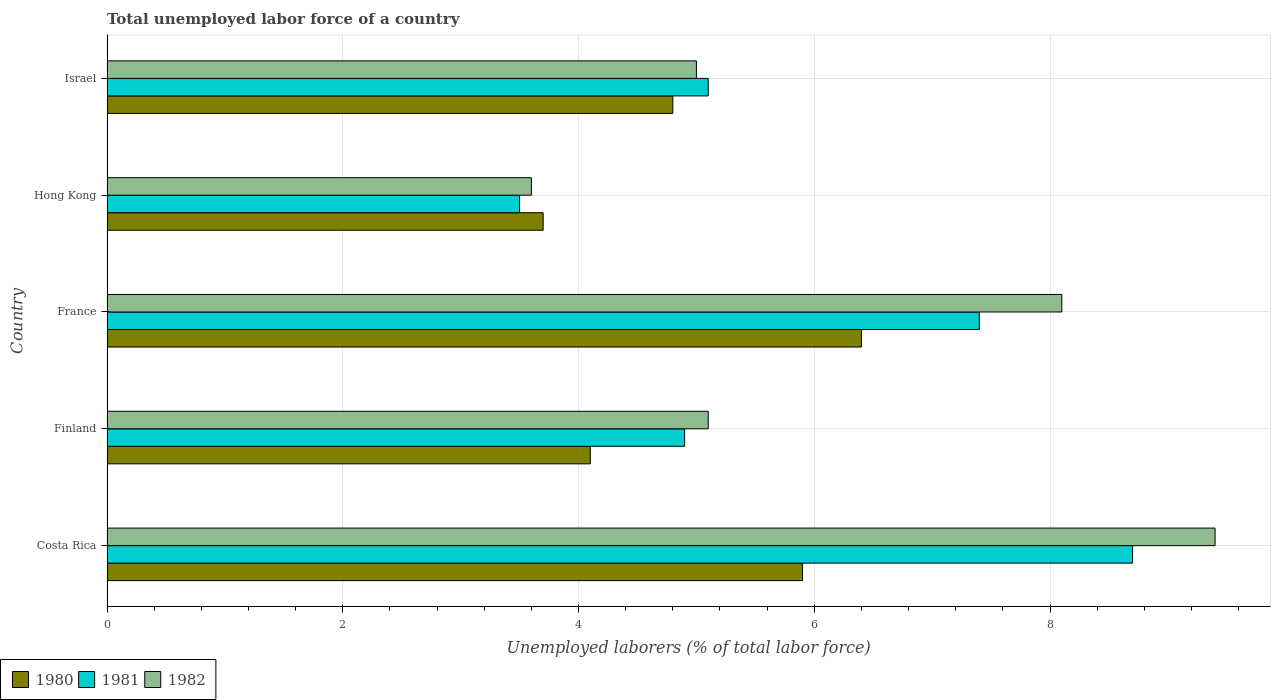How many different coloured bars are there?
Your response must be concise. 3. Are the number of bars per tick equal to the number of legend labels?
Provide a short and direct response. Yes. Are the number of bars on each tick of the Y-axis equal?
Provide a succinct answer. Yes. How many bars are there on the 1st tick from the top?
Keep it short and to the point. 3. How many bars are there on the 5th tick from the bottom?
Give a very brief answer. 3. What is the label of the 1st group of bars from the top?
Keep it short and to the point. Israel. What is the total unemployed labor force in 1981 in Israel?
Your answer should be compact. 5.1. Across all countries, what is the maximum total unemployed labor force in 1980?
Make the answer very short. 6.4. In which country was the total unemployed labor force in 1980 maximum?
Your response must be concise. France. In which country was the total unemployed labor force in 1980 minimum?
Give a very brief answer. Hong Kong. What is the total total unemployed labor force in 1980 in the graph?
Give a very brief answer. 24.9. What is the difference between the total unemployed labor force in 1981 in Finland and that in Hong Kong?
Provide a succinct answer. 1.4. What is the difference between the total unemployed labor force in 1982 in Israel and the total unemployed labor force in 1980 in Hong Kong?
Provide a succinct answer. 1.3. What is the average total unemployed labor force in 1980 per country?
Keep it short and to the point. 4.98. What is the difference between the total unemployed labor force in 1981 and total unemployed labor force in 1980 in Costa Rica?
Keep it short and to the point. 2.8. What is the ratio of the total unemployed labor force in 1982 in France to that in Hong Kong?
Offer a terse response. 2.25. Is the total unemployed labor force in 1980 in Costa Rica less than that in Israel?
Offer a very short reply. No. What is the difference between the highest and the second highest total unemployed labor force in 1981?
Offer a very short reply. 1.3. What is the difference between the highest and the lowest total unemployed labor force in 1980?
Provide a succinct answer. 2.7. What does the 3rd bar from the top in Finland represents?
Make the answer very short. 1980. What does the 3rd bar from the bottom in Israel represents?
Ensure brevity in your answer.  1982. Is it the case that in every country, the sum of the total unemployed labor force in 1982 and total unemployed labor force in 1981 is greater than the total unemployed labor force in 1980?
Your answer should be compact. Yes. How many bars are there?
Offer a very short reply. 15. How many countries are there in the graph?
Offer a terse response. 5. Does the graph contain grids?
Offer a very short reply. Yes. How many legend labels are there?
Offer a terse response. 3. What is the title of the graph?
Ensure brevity in your answer.  Total unemployed labor force of a country. What is the label or title of the X-axis?
Keep it short and to the point. Unemployed laborers (% of total labor force). What is the label or title of the Y-axis?
Make the answer very short. Country. What is the Unemployed laborers (% of total labor force) of 1980 in Costa Rica?
Your answer should be compact. 5.9. What is the Unemployed laborers (% of total labor force) of 1981 in Costa Rica?
Make the answer very short. 8.7. What is the Unemployed laborers (% of total labor force) in 1982 in Costa Rica?
Keep it short and to the point. 9.4. What is the Unemployed laborers (% of total labor force) in 1980 in Finland?
Provide a short and direct response. 4.1. What is the Unemployed laborers (% of total labor force) of 1981 in Finland?
Offer a terse response. 4.9. What is the Unemployed laborers (% of total labor force) in 1982 in Finland?
Give a very brief answer. 5.1. What is the Unemployed laborers (% of total labor force) of 1980 in France?
Make the answer very short. 6.4. What is the Unemployed laborers (% of total labor force) in 1981 in France?
Offer a terse response. 7.4. What is the Unemployed laborers (% of total labor force) of 1982 in France?
Ensure brevity in your answer.  8.1. What is the Unemployed laborers (% of total labor force) of 1980 in Hong Kong?
Offer a terse response. 3.7. What is the Unemployed laborers (% of total labor force) of 1981 in Hong Kong?
Your response must be concise. 3.5. What is the Unemployed laborers (% of total labor force) in 1982 in Hong Kong?
Offer a very short reply. 3.6. What is the Unemployed laborers (% of total labor force) of 1980 in Israel?
Offer a very short reply. 4.8. What is the Unemployed laborers (% of total labor force) of 1981 in Israel?
Make the answer very short. 5.1. What is the Unemployed laborers (% of total labor force) in 1982 in Israel?
Offer a terse response. 5. Across all countries, what is the maximum Unemployed laborers (% of total labor force) in 1980?
Offer a very short reply. 6.4. Across all countries, what is the maximum Unemployed laborers (% of total labor force) in 1981?
Offer a very short reply. 8.7. Across all countries, what is the maximum Unemployed laborers (% of total labor force) of 1982?
Your response must be concise. 9.4. Across all countries, what is the minimum Unemployed laborers (% of total labor force) in 1980?
Your answer should be very brief. 3.7. Across all countries, what is the minimum Unemployed laborers (% of total labor force) of 1982?
Offer a terse response. 3.6. What is the total Unemployed laborers (% of total labor force) of 1980 in the graph?
Make the answer very short. 24.9. What is the total Unemployed laborers (% of total labor force) in 1981 in the graph?
Offer a terse response. 29.6. What is the total Unemployed laborers (% of total labor force) of 1982 in the graph?
Provide a short and direct response. 31.2. What is the difference between the Unemployed laborers (% of total labor force) in 1980 in Costa Rica and that in Finland?
Provide a short and direct response. 1.8. What is the difference between the Unemployed laborers (% of total labor force) in 1981 in Costa Rica and that in Finland?
Your response must be concise. 3.8. What is the difference between the Unemployed laborers (% of total labor force) of 1980 in Costa Rica and that in France?
Provide a succinct answer. -0.5. What is the difference between the Unemployed laborers (% of total labor force) in 1981 in Costa Rica and that in France?
Your response must be concise. 1.3. What is the difference between the Unemployed laborers (% of total labor force) of 1982 in Costa Rica and that in France?
Give a very brief answer. 1.3. What is the difference between the Unemployed laborers (% of total labor force) in 1982 in Costa Rica and that in Israel?
Offer a very short reply. 4.4. What is the difference between the Unemployed laborers (% of total labor force) of 1982 in Finland and that in France?
Make the answer very short. -3. What is the difference between the Unemployed laborers (% of total labor force) of 1981 in Finland and that in Israel?
Keep it short and to the point. -0.2. What is the difference between the Unemployed laborers (% of total labor force) of 1980 in France and that in Hong Kong?
Offer a very short reply. 2.7. What is the difference between the Unemployed laborers (% of total labor force) of 1982 in France and that in Hong Kong?
Offer a terse response. 4.5. What is the difference between the Unemployed laborers (% of total labor force) in 1981 in France and that in Israel?
Your answer should be compact. 2.3. What is the difference between the Unemployed laborers (% of total labor force) in 1982 in Hong Kong and that in Israel?
Give a very brief answer. -1.4. What is the difference between the Unemployed laborers (% of total labor force) in 1980 in Costa Rica and the Unemployed laborers (% of total labor force) in 1981 in Finland?
Your response must be concise. 1. What is the difference between the Unemployed laborers (% of total labor force) of 1980 in Costa Rica and the Unemployed laborers (% of total labor force) of 1982 in Finland?
Offer a very short reply. 0.8. What is the difference between the Unemployed laborers (% of total labor force) of 1981 in Costa Rica and the Unemployed laborers (% of total labor force) of 1982 in Finland?
Give a very brief answer. 3.6. What is the difference between the Unemployed laborers (% of total labor force) in 1981 in Costa Rica and the Unemployed laborers (% of total labor force) in 1982 in France?
Make the answer very short. 0.6. What is the difference between the Unemployed laborers (% of total labor force) of 1980 in Costa Rica and the Unemployed laborers (% of total labor force) of 1981 in Hong Kong?
Your answer should be compact. 2.4. What is the difference between the Unemployed laborers (% of total labor force) of 1980 in Costa Rica and the Unemployed laborers (% of total labor force) of 1982 in Hong Kong?
Your response must be concise. 2.3. What is the difference between the Unemployed laborers (% of total labor force) of 1981 in Costa Rica and the Unemployed laborers (% of total labor force) of 1982 in Hong Kong?
Provide a short and direct response. 5.1. What is the difference between the Unemployed laborers (% of total labor force) of 1980 in Costa Rica and the Unemployed laborers (% of total labor force) of 1981 in Israel?
Your answer should be compact. 0.8. What is the difference between the Unemployed laborers (% of total labor force) in 1980 in Finland and the Unemployed laborers (% of total labor force) in 1982 in France?
Offer a terse response. -4. What is the difference between the Unemployed laborers (% of total labor force) of 1980 in Finland and the Unemployed laborers (% of total labor force) of 1982 in Hong Kong?
Ensure brevity in your answer.  0.5. What is the difference between the Unemployed laborers (% of total labor force) in 1980 in Finland and the Unemployed laborers (% of total labor force) in 1981 in Israel?
Offer a very short reply. -1. What is the difference between the Unemployed laborers (% of total labor force) in 1980 in France and the Unemployed laborers (% of total labor force) in 1981 in Hong Kong?
Make the answer very short. 2.9. What is the difference between the Unemployed laborers (% of total labor force) of 1980 in France and the Unemployed laborers (% of total labor force) of 1982 in Hong Kong?
Make the answer very short. 2.8. What is the difference between the Unemployed laborers (% of total labor force) of 1981 in France and the Unemployed laborers (% of total labor force) of 1982 in Hong Kong?
Make the answer very short. 3.8. What is the difference between the Unemployed laborers (% of total labor force) in 1980 in France and the Unemployed laborers (% of total labor force) in 1982 in Israel?
Make the answer very short. 1.4. What is the difference between the Unemployed laborers (% of total labor force) in 1981 in France and the Unemployed laborers (% of total labor force) in 1982 in Israel?
Offer a terse response. 2.4. What is the difference between the Unemployed laborers (% of total labor force) of 1980 in Hong Kong and the Unemployed laborers (% of total labor force) of 1981 in Israel?
Your answer should be very brief. -1.4. What is the difference between the Unemployed laborers (% of total labor force) in 1980 in Hong Kong and the Unemployed laborers (% of total labor force) in 1982 in Israel?
Provide a short and direct response. -1.3. What is the average Unemployed laborers (% of total labor force) of 1980 per country?
Give a very brief answer. 4.98. What is the average Unemployed laborers (% of total labor force) in 1981 per country?
Provide a short and direct response. 5.92. What is the average Unemployed laborers (% of total labor force) in 1982 per country?
Your answer should be compact. 6.24. What is the difference between the Unemployed laborers (% of total labor force) of 1980 and Unemployed laborers (% of total labor force) of 1981 in Costa Rica?
Provide a succinct answer. -2.8. What is the difference between the Unemployed laborers (% of total labor force) of 1981 and Unemployed laborers (% of total labor force) of 1982 in Costa Rica?
Provide a succinct answer. -0.7. What is the difference between the Unemployed laborers (% of total labor force) of 1980 and Unemployed laborers (% of total labor force) of 1981 in Finland?
Offer a very short reply. -0.8. What is the difference between the Unemployed laborers (% of total labor force) of 1980 and Unemployed laborers (% of total labor force) of 1982 in France?
Offer a terse response. -1.7. What is the difference between the Unemployed laborers (% of total labor force) in 1980 and Unemployed laborers (% of total labor force) in 1981 in Hong Kong?
Your answer should be very brief. 0.2. What is the difference between the Unemployed laborers (% of total labor force) of 1980 and Unemployed laborers (% of total labor force) of 1982 in Hong Kong?
Provide a succinct answer. 0.1. What is the difference between the Unemployed laborers (% of total labor force) of 1981 and Unemployed laborers (% of total labor force) of 1982 in Hong Kong?
Make the answer very short. -0.1. What is the ratio of the Unemployed laborers (% of total labor force) in 1980 in Costa Rica to that in Finland?
Offer a very short reply. 1.44. What is the ratio of the Unemployed laborers (% of total labor force) in 1981 in Costa Rica to that in Finland?
Make the answer very short. 1.78. What is the ratio of the Unemployed laborers (% of total labor force) in 1982 in Costa Rica to that in Finland?
Provide a short and direct response. 1.84. What is the ratio of the Unemployed laborers (% of total labor force) in 1980 in Costa Rica to that in France?
Ensure brevity in your answer.  0.92. What is the ratio of the Unemployed laborers (% of total labor force) in 1981 in Costa Rica to that in France?
Give a very brief answer. 1.18. What is the ratio of the Unemployed laborers (% of total labor force) of 1982 in Costa Rica to that in France?
Give a very brief answer. 1.16. What is the ratio of the Unemployed laborers (% of total labor force) in 1980 in Costa Rica to that in Hong Kong?
Your answer should be compact. 1.59. What is the ratio of the Unemployed laborers (% of total labor force) in 1981 in Costa Rica to that in Hong Kong?
Your answer should be compact. 2.49. What is the ratio of the Unemployed laborers (% of total labor force) in 1982 in Costa Rica to that in Hong Kong?
Provide a short and direct response. 2.61. What is the ratio of the Unemployed laborers (% of total labor force) in 1980 in Costa Rica to that in Israel?
Give a very brief answer. 1.23. What is the ratio of the Unemployed laborers (% of total labor force) of 1981 in Costa Rica to that in Israel?
Ensure brevity in your answer.  1.71. What is the ratio of the Unemployed laborers (% of total labor force) in 1982 in Costa Rica to that in Israel?
Provide a short and direct response. 1.88. What is the ratio of the Unemployed laborers (% of total labor force) in 1980 in Finland to that in France?
Give a very brief answer. 0.64. What is the ratio of the Unemployed laborers (% of total labor force) of 1981 in Finland to that in France?
Your answer should be very brief. 0.66. What is the ratio of the Unemployed laborers (% of total labor force) of 1982 in Finland to that in France?
Keep it short and to the point. 0.63. What is the ratio of the Unemployed laborers (% of total labor force) in 1980 in Finland to that in Hong Kong?
Give a very brief answer. 1.11. What is the ratio of the Unemployed laborers (% of total labor force) in 1981 in Finland to that in Hong Kong?
Keep it short and to the point. 1.4. What is the ratio of the Unemployed laborers (% of total labor force) of 1982 in Finland to that in Hong Kong?
Your answer should be compact. 1.42. What is the ratio of the Unemployed laborers (% of total labor force) in 1980 in Finland to that in Israel?
Give a very brief answer. 0.85. What is the ratio of the Unemployed laborers (% of total labor force) in 1981 in Finland to that in Israel?
Your answer should be compact. 0.96. What is the ratio of the Unemployed laborers (% of total labor force) in 1980 in France to that in Hong Kong?
Give a very brief answer. 1.73. What is the ratio of the Unemployed laborers (% of total labor force) in 1981 in France to that in Hong Kong?
Your response must be concise. 2.11. What is the ratio of the Unemployed laborers (% of total labor force) of 1982 in France to that in Hong Kong?
Ensure brevity in your answer.  2.25. What is the ratio of the Unemployed laborers (% of total labor force) in 1981 in France to that in Israel?
Make the answer very short. 1.45. What is the ratio of the Unemployed laborers (% of total labor force) of 1982 in France to that in Israel?
Offer a very short reply. 1.62. What is the ratio of the Unemployed laborers (% of total labor force) in 1980 in Hong Kong to that in Israel?
Provide a succinct answer. 0.77. What is the ratio of the Unemployed laborers (% of total labor force) of 1981 in Hong Kong to that in Israel?
Provide a succinct answer. 0.69. What is the ratio of the Unemployed laborers (% of total labor force) of 1982 in Hong Kong to that in Israel?
Give a very brief answer. 0.72. What is the difference between the highest and the second highest Unemployed laborers (% of total labor force) in 1980?
Your answer should be very brief. 0.5. What is the difference between the highest and the lowest Unemployed laborers (% of total labor force) of 1982?
Provide a succinct answer. 5.8. 